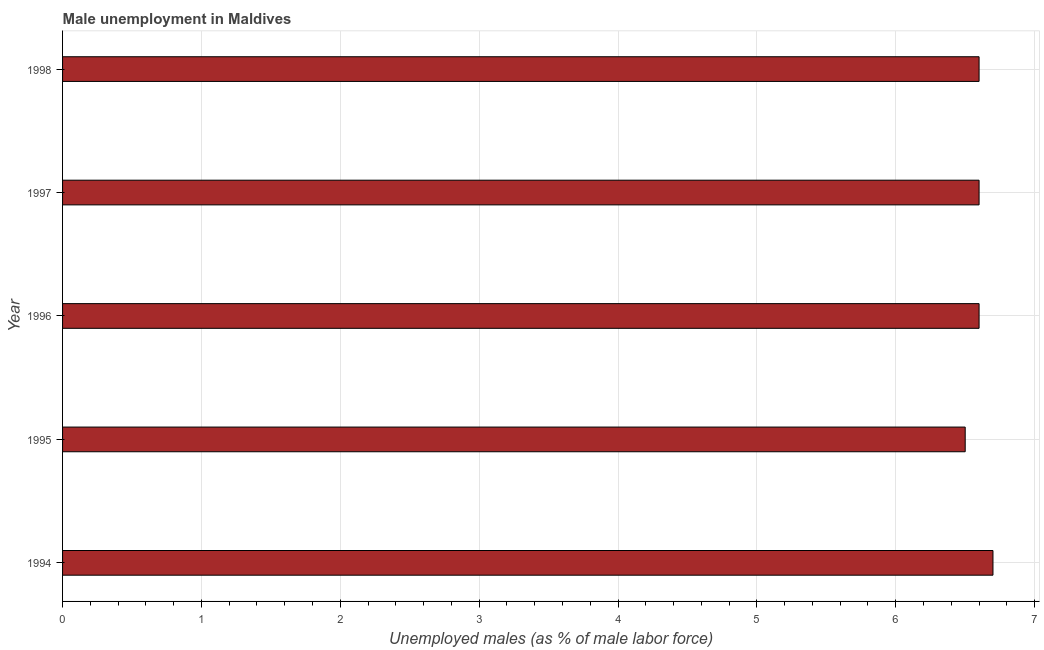Does the graph contain any zero values?
Make the answer very short. No. Does the graph contain grids?
Offer a very short reply. Yes. What is the title of the graph?
Offer a terse response. Male unemployment in Maldives. What is the label or title of the X-axis?
Provide a succinct answer. Unemployed males (as % of male labor force). What is the label or title of the Y-axis?
Offer a terse response. Year. What is the unemployed males population in 1997?
Your response must be concise. 6.6. Across all years, what is the maximum unemployed males population?
Your response must be concise. 6.7. Across all years, what is the minimum unemployed males population?
Ensure brevity in your answer.  6.5. In which year was the unemployed males population maximum?
Offer a very short reply. 1994. In which year was the unemployed males population minimum?
Ensure brevity in your answer.  1995. What is the sum of the unemployed males population?
Your response must be concise. 33. What is the difference between the unemployed males population in 1996 and 1997?
Offer a very short reply. 0. What is the median unemployed males population?
Provide a succinct answer. 6.6. Do a majority of the years between 1994 and 1996 (inclusive) have unemployed males population greater than 3 %?
Make the answer very short. Yes. Is the unemployed males population in 1996 less than that in 1998?
Offer a very short reply. No. Is the sum of the unemployed males population in 1995 and 1997 greater than the maximum unemployed males population across all years?
Ensure brevity in your answer.  Yes. What is the difference between the highest and the lowest unemployed males population?
Provide a succinct answer. 0.2. In how many years, is the unemployed males population greater than the average unemployed males population taken over all years?
Give a very brief answer. 1. How many years are there in the graph?
Provide a succinct answer. 5. What is the Unemployed males (as % of male labor force) in 1994?
Offer a terse response. 6.7. What is the Unemployed males (as % of male labor force) in 1995?
Provide a succinct answer. 6.5. What is the Unemployed males (as % of male labor force) of 1996?
Make the answer very short. 6.6. What is the Unemployed males (as % of male labor force) in 1997?
Offer a very short reply. 6.6. What is the Unemployed males (as % of male labor force) in 1998?
Keep it short and to the point. 6.6. What is the difference between the Unemployed males (as % of male labor force) in 1994 and 1998?
Offer a very short reply. 0.1. What is the difference between the Unemployed males (as % of male labor force) in 1995 and 1996?
Your response must be concise. -0.1. What is the difference between the Unemployed males (as % of male labor force) in 1995 and 1997?
Offer a terse response. -0.1. What is the difference between the Unemployed males (as % of male labor force) in 1995 and 1998?
Make the answer very short. -0.1. What is the difference between the Unemployed males (as % of male labor force) in 1996 and 1997?
Make the answer very short. 0. What is the ratio of the Unemployed males (as % of male labor force) in 1994 to that in 1995?
Ensure brevity in your answer.  1.03. What is the ratio of the Unemployed males (as % of male labor force) in 1994 to that in 1996?
Provide a succinct answer. 1.01. What is the ratio of the Unemployed males (as % of male labor force) in 1994 to that in 1997?
Offer a terse response. 1.01. What is the ratio of the Unemployed males (as % of male labor force) in 1994 to that in 1998?
Offer a very short reply. 1.01. What is the ratio of the Unemployed males (as % of male labor force) in 1995 to that in 1996?
Your response must be concise. 0.98. What is the ratio of the Unemployed males (as % of male labor force) in 1995 to that in 1998?
Make the answer very short. 0.98. What is the ratio of the Unemployed males (as % of male labor force) in 1997 to that in 1998?
Your answer should be compact. 1. 